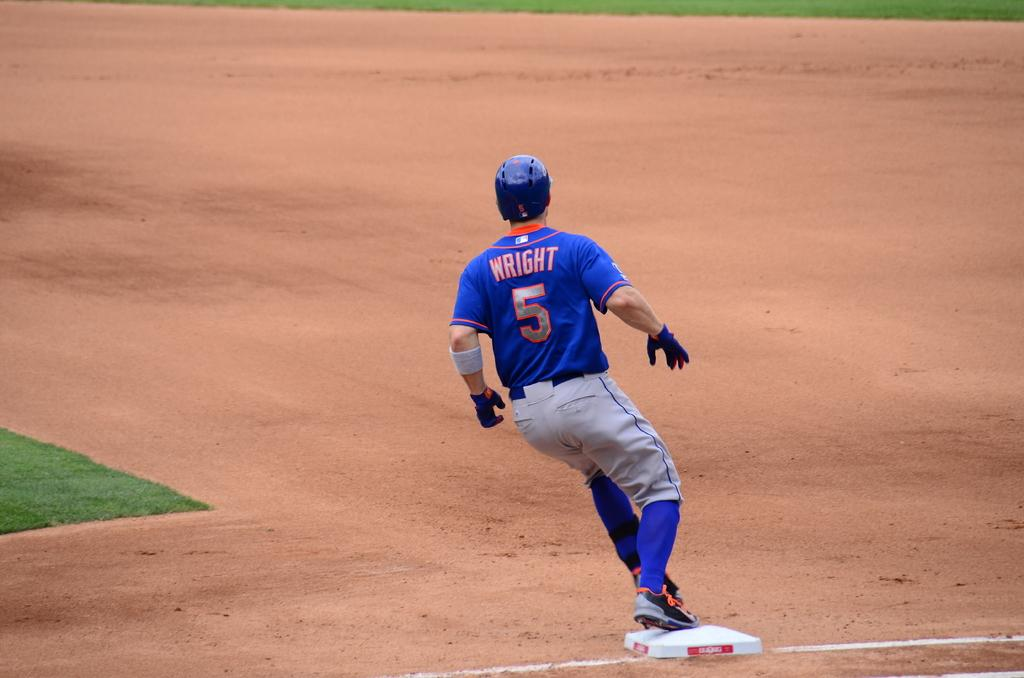<image>
Write a terse but informative summary of the picture. A baseball player is running on a base and his uniform says Wright 5. 